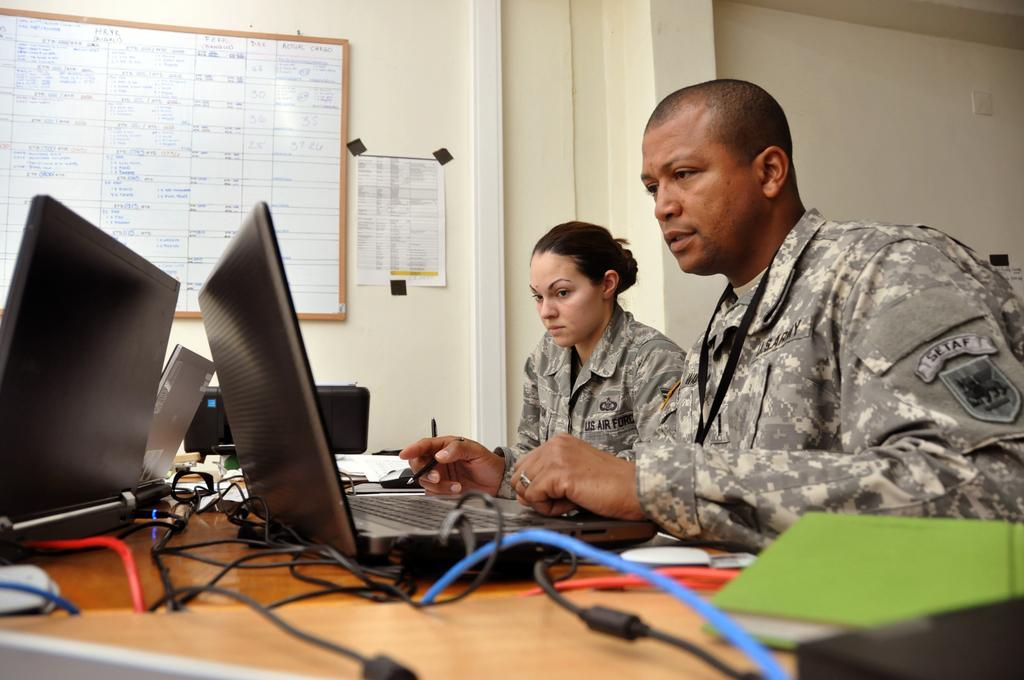<image>
Write a terse but informative summary of the picture. Two people sitting at a desk from the US air force. 